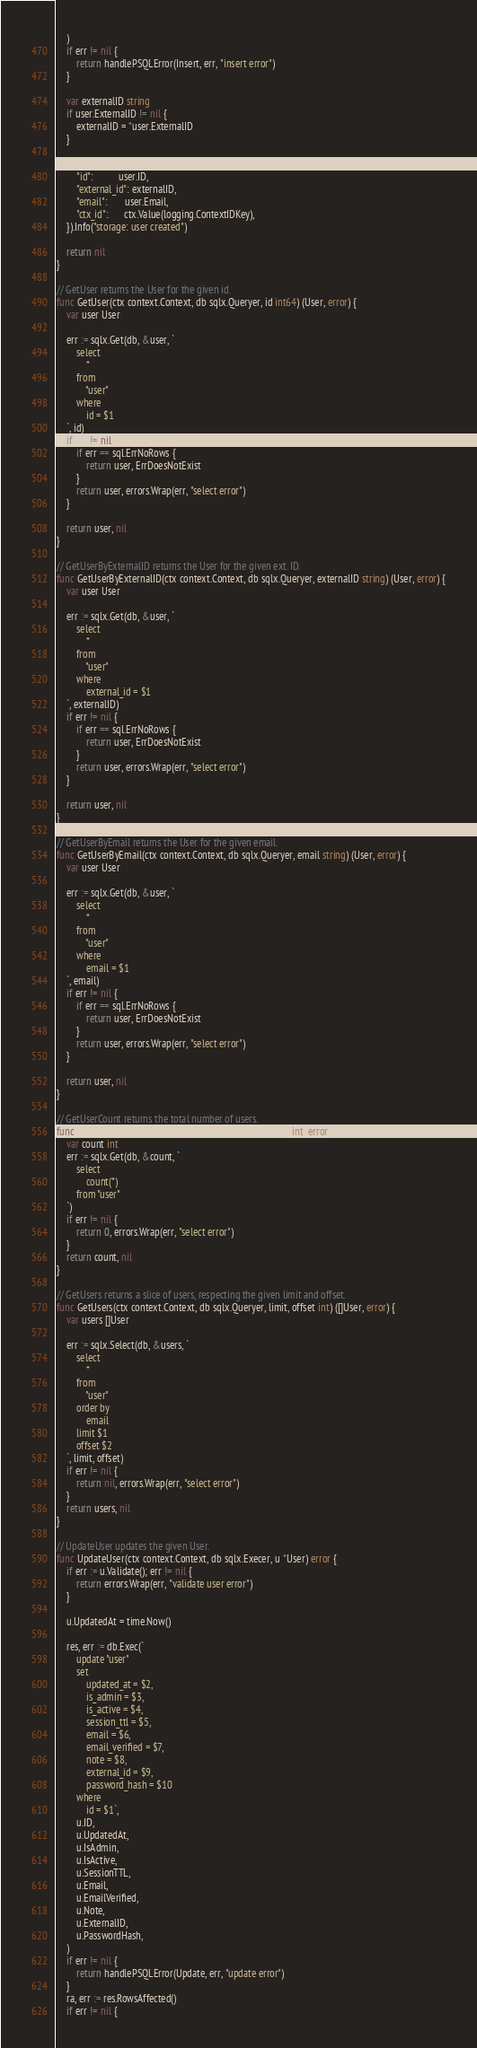Convert code to text. <code><loc_0><loc_0><loc_500><loc_500><_Go_>	)
	if err != nil {
		return handlePSQLError(Insert, err, "insert error")
	}

	var externalID string
	if user.ExternalID != nil {
		externalID = *user.ExternalID
	}

	log.WithFields(log.Fields{
		"id":          user.ID,
		"external_id": externalID,
		"email":       user.Email,
		"ctx_id":      ctx.Value(logging.ContextIDKey),
	}).Info("storage: user created")

	return nil
}

// GetUser returns the User for the given id.
func GetUser(ctx context.Context, db sqlx.Queryer, id int64) (User, error) {
	var user User

	err := sqlx.Get(db, &user, `
		select
			*
		from
			"user"
		where
			id = $1
	`, id)
	if err != nil {
		if err == sql.ErrNoRows {
			return user, ErrDoesNotExist
		}
		return user, errors.Wrap(err, "select error")
	}

	return user, nil
}

// GetUserByExternalID returns the User for the given ext. ID.
func GetUserByExternalID(ctx context.Context, db sqlx.Queryer, externalID string) (User, error) {
	var user User

	err := sqlx.Get(db, &user, `
		select
			*
		from
			"user"
		where
			external_id = $1
	`, externalID)
	if err != nil {
		if err == sql.ErrNoRows {
			return user, ErrDoesNotExist
		}
		return user, errors.Wrap(err, "select error")
	}

	return user, nil
}

// GetUserByEmail returns the User for the given email.
func GetUserByEmail(ctx context.Context, db sqlx.Queryer, email string) (User, error) {
	var user User

	err := sqlx.Get(db, &user, `
		select
			*
		from
			"user"
		where
			email = $1
	`, email)
	if err != nil {
		if err == sql.ErrNoRows {
			return user, ErrDoesNotExist
		}
		return user, errors.Wrap(err, "select error")
	}

	return user, nil
}

// GetUserCount returns the total number of users.
func GetUserCount(ctx context.Context, db sqlx.Queryer) (int, error) {
	var count int
	err := sqlx.Get(db, &count, `
		select
			count(*)
		from "user"
	`)
	if err != nil {
		return 0, errors.Wrap(err, "select error")
	}
	return count, nil
}

// GetUsers returns a slice of users, respecting the given limit and offset.
func GetUsers(ctx context.Context, db sqlx.Queryer, limit, offset int) ([]User, error) {
	var users []User

	err := sqlx.Select(db, &users, `
		select
			*
		from
			"user"
		order by
			email
		limit $1
		offset $2
	`, limit, offset)
	if err != nil {
		return nil, errors.Wrap(err, "select error")
	}
	return users, nil
}

// UpdateUser updates the given User.
func UpdateUser(ctx context.Context, db sqlx.Execer, u *User) error {
	if err := u.Validate(); err != nil {
		return errors.Wrap(err, "validate user error")
	}

	u.UpdatedAt = time.Now()

	res, err := db.Exec(`
		update "user"
		set
			updated_at = $2,
			is_admin = $3,
			is_active = $4,
			session_ttl = $5,
			email = $6,
			email_verified = $7,
			note = $8,
			external_id = $9,
			password_hash = $10
		where
			id = $1`,
		u.ID,
		u.UpdatedAt,
		u.IsAdmin,
		u.IsActive,
		u.SessionTTL,
		u.Email,
		u.EmailVerified,
		u.Note,
		u.ExternalID,
		u.PasswordHash,
	)
	if err != nil {
		return handlePSQLError(Update, err, "update error")
	}
	ra, err := res.RowsAffected()
	if err != nil {</code> 